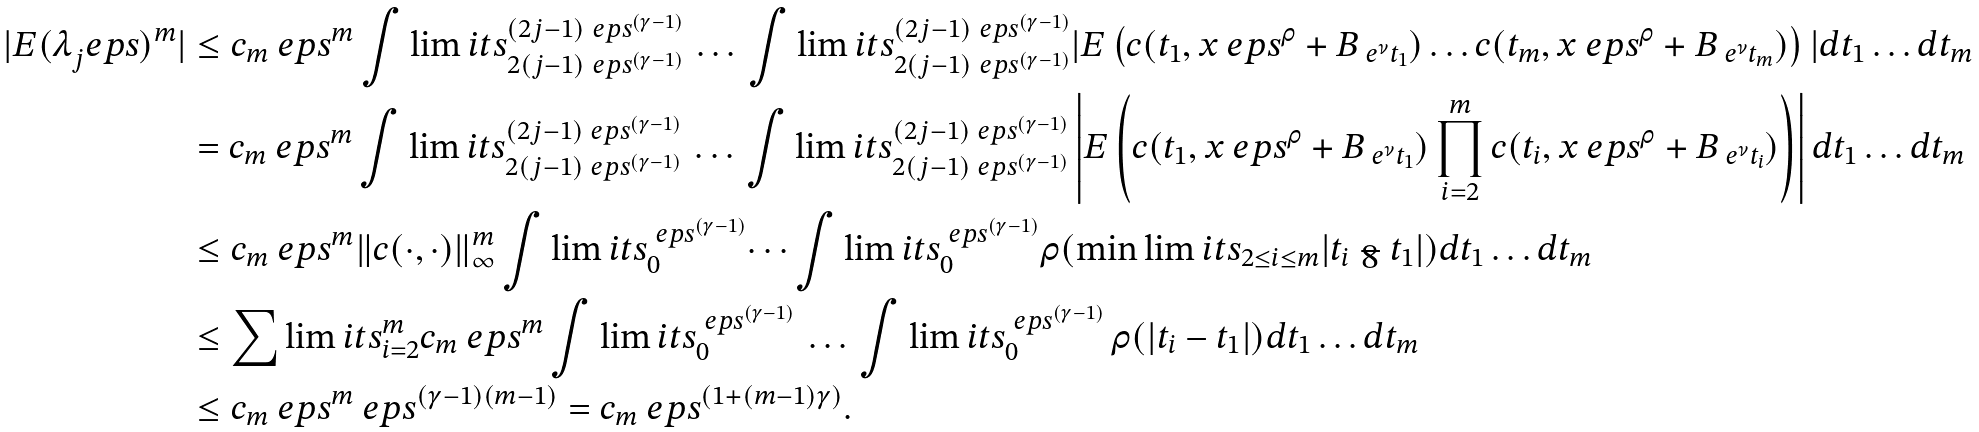Convert formula to latex. <formula><loc_0><loc_0><loc_500><loc_500>| E ( \lambda _ { j } ^ { \ } e p s ) ^ { m } | & \leq c _ { m } \ e p s ^ { m } \int \lim i t s _ { 2 ( j - 1 ) \ e p s ^ { ( \gamma - 1 ) } } ^ { ( 2 j - 1 ) \ e p s ^ { ( \gamma - 1 ) } } \, \dots \, \int \lim i t s _ { 2 ( j - 1 ) \ e p s ^ { ( \gamma - 1 ) } } ^ { ( 2 j - 1 ) \ e p s ^ { ( \gamma - 1 ) } } | E \left ( c ( t _ { 1 } , x \ e p s ^ { \rho } + B _ { \ e ^ { \nu } t _ { 1 } } ) \dots c ( t _ { m } , x \ e p s ^ { \rho } + B _ { \ e ^ { \nu } t _ { m } } ) \right ) | d t _ { 1 } \dots d t _ { m } \\ & = c _ { m } \ e p s ^ { m } \int \lim i t s _ { 2 ( j - 1 ) \ e p s ^ { ( \gamma - 1 ) } } ^ { ( 2 j - 1 ) \ e p s ^ { ( \gamma - 1 ) } } \, \dots \, \int \lim i t s _ { 2 ( j - 1 ) \ e p s ^ { ( \gamma - 1 ) } } ^ { ( 2 j - 1 ) \ e p s ^ { ( \gamma - 1 ) } } \left | E \left ( c ( t _ { 1 } , x \ e p s ^ { \rho } + B _ { \ e ^ { \nu } t _ { 1 } } ) \prod _ { i = 2 } ^ { m } c ( t _ { i } , x \ e p s ^ { \rho } + B _ { \ e ^ { \nu } t _ { i } } ) \right ) \right | d t _ { 1 } \dots d t _ { m } \\ & \leq c _ { m } \ e p s ^ { m } \| c ( \cdot , \cdot ) \| ^ { m } _ { \infty } \int \lim i t s _ { 0 } ^ { \ e p s ^ { ( \gamma - 1 ) } } \dots \int \lim i t s _ { 0 } ^ { \ e p s ^ { ( \gamma - 1 ) } } \rho ( \min \lim i t s _ { 2 \leq i \leq m } | t _ { i } - t _ { 1 } | ) d t _ { 1 } \dots d t _ { m } \\ & \leq \sum \lim i t s _ { i = 2 } ^ { m } c _ { m } \ e p s ^ { m } \int \lim i t s _ { 0 } ^ { \ e p s ^ { ( \gamma - 1 ) } } \, \dots \, \int \lim i t s _ { 0 } ^ { \ e p s ^ { ( \gamma - 1 ) } } \, \rho ( | t _ { i } - t _ { 1 } | ) d t _ { 1 } \dots d t _ { m } \\ & \leq c _ { m } \ e p s ^ { m } \ e p s ^ { ( \gamma - 1 ) ( m - 1 ) } = c _ { m } \ e p s ^ { ( 1 + ( m - 1 ) \gamma ) } .</formula> 